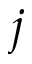<formula> <loc_0><loc_0><loc_500><loc_500>j</formula> 